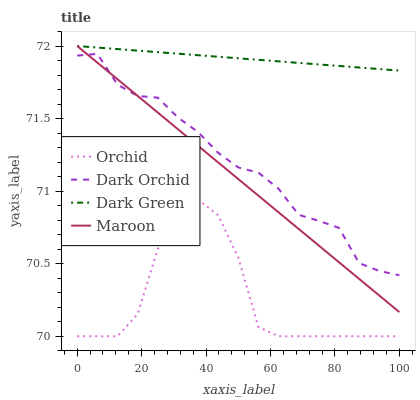Does Orchid have the minimum area under the curve?
Answer yes or no. Yes. Does Dark Green have the maximum area under the curve?
Answer yes or no. Yes. Does Maroon have the minimum area under the curve?
Answer yes or no. No. Does Maroon have the maximum area under the curve?
Answer yes or no. No. Is Dark Green the smoothest?
Answer yes or no. Yes. Is Orchid the roughest?
Answer yes or no. Yes. Is Maroon the smoothest?
Answer yes or no. No. Is Maroon the roughest?
Answer yes or no. No. Does Orchid have the lowest value?
Answer yes or no. Yes. Does Maroon have the lowest value?
Answer yes or no. No. Does Maroon have the highest value?
Answer yes or no. Yes. Does Dark Orchid have the highest value?
Answer yes or no. No. Is Dark Orchid less than Dark Green?
Answer yes or no. Yes. Is Dark Green greater than Dark Orchid?
Answer yes or no. Yes. Does Maroon intersect Dark Orchid?
Answer yes or no. Yes. Is Maroon less than Dark Orchid?
Answer yes or no. No. Is Maroon greater than Dark Orchid?
Answer yes or no. No. Does Dark Orchid intersect Dark Green?
Answer yes or no. No. 